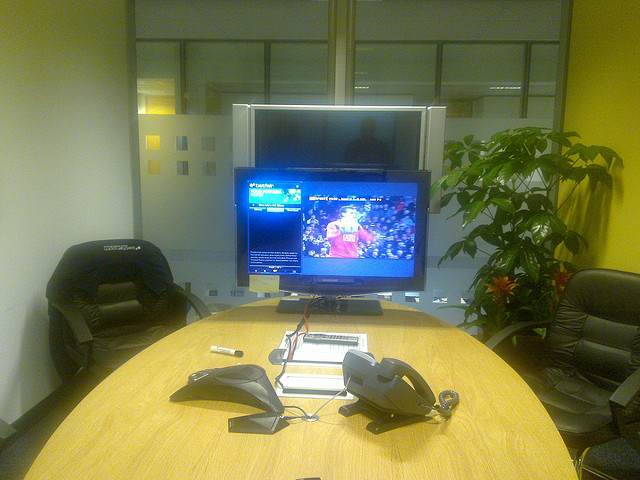<image>Is there a sound station on the desk? I am not certain if there is a sound station on the desk. Is there a sound station on the desk? I don't know if there is a sound station on the desk. It can be both yes or no. 